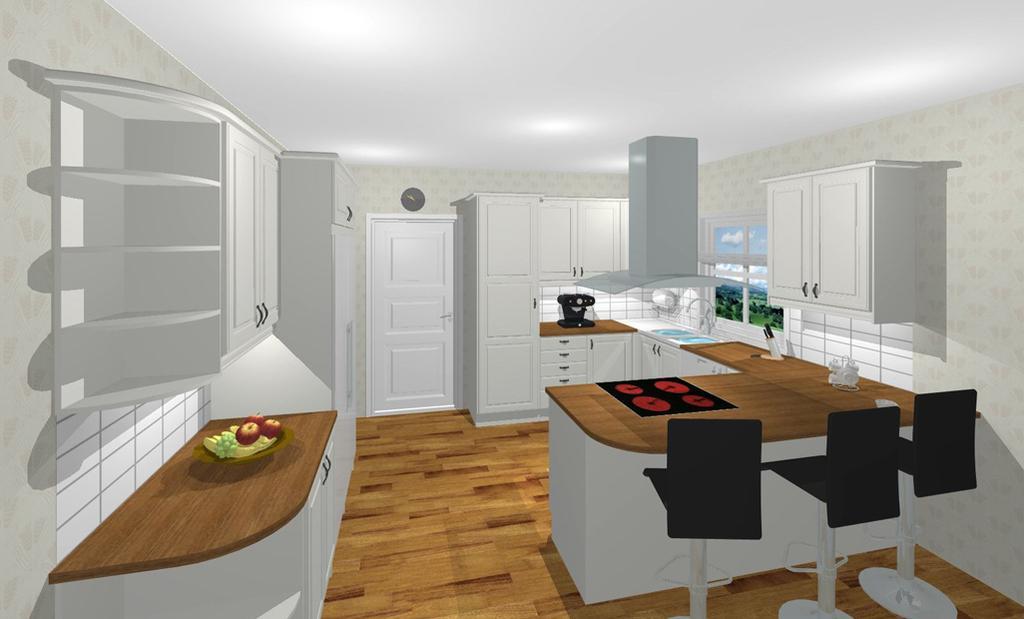In one or two sentences, can you explain what this image depicts? In this picture there are few chairs and there is a table in front of it and there is a cupboard in the right corner and there are few fruits and cupboards in the left corner and there is a door in the background. 